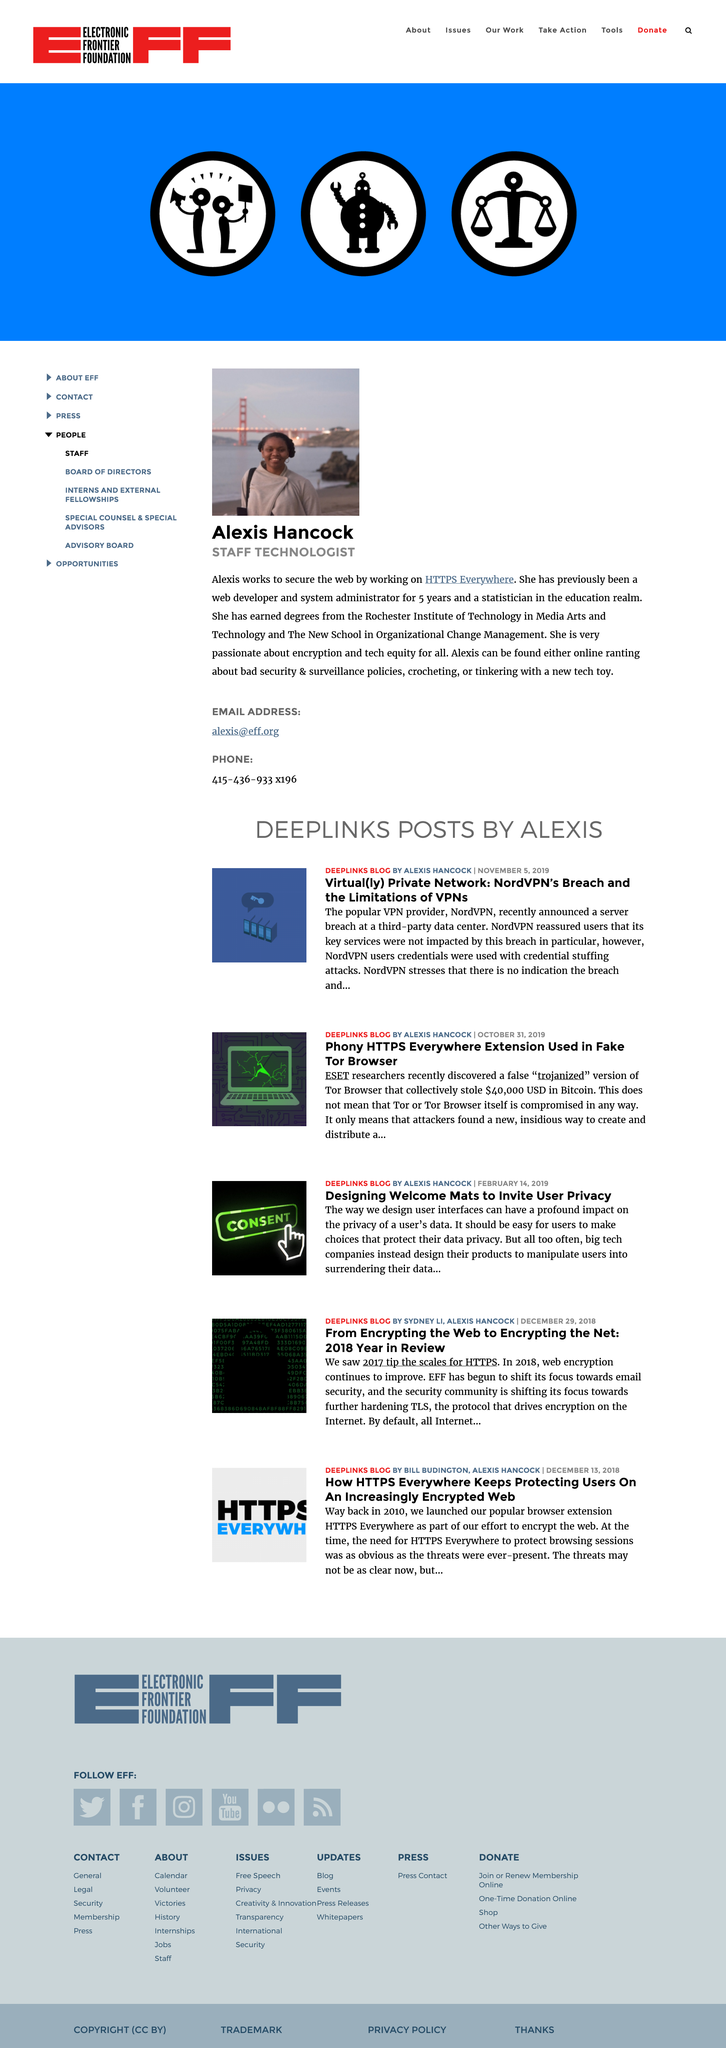Specify some key components in this picture. Alexis Hancock is a Staff Technologist at HTTPS Everywhere who holds a job position. Alexis Hancock earned a degree in electrical engineering from Rochester Institute of Technology. Alexis Hancock's primary hobbies include posting online about bad security and surveillance policies, critically analyzing and protecting, and engaging in activities related to tinkering with new technological devices. 